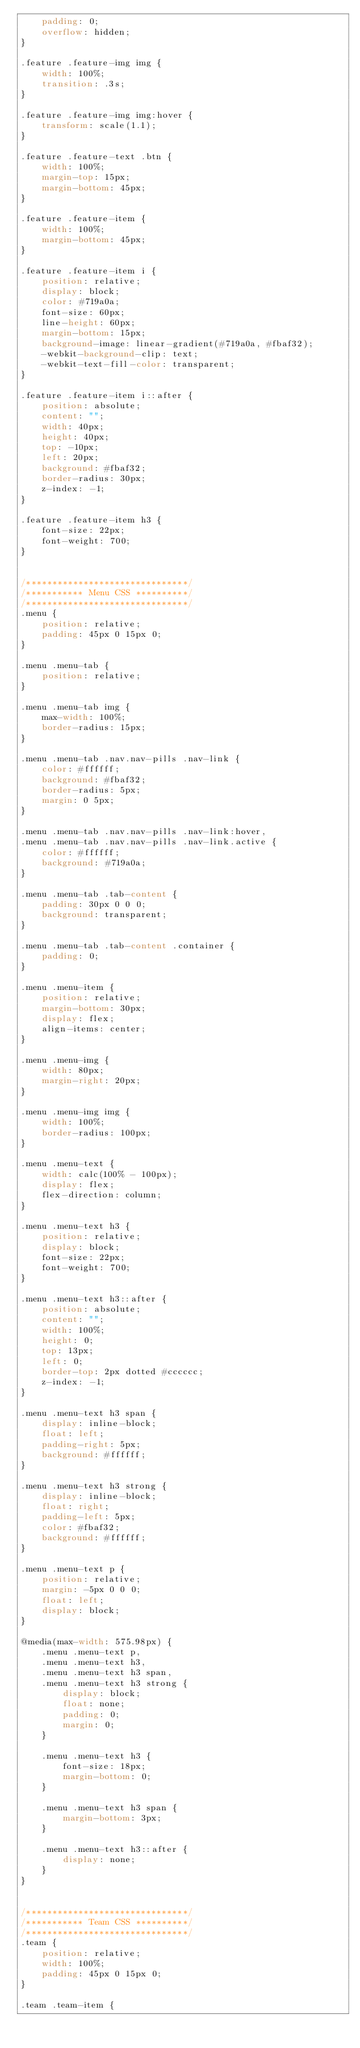<code> <loc_0><loc_0><loc_500><loc_500><_CSS_>    padding: 0;
    overflow: hidden;
}

.feature .feature-img img {
    width: 100%;
    transition: .3s;
}

.feature .feature-img img:hover {
    transform: scale(1.1);
}

.feature .feature-text .btn {
    width: 100%;
    margin-top: 15px;
    margin-bottom: 45px;
}

.feature .feature-item {
    width: 100%;
    margin-bottom: 45px;
}

.feature .feature-item i {
    position: relative;
    display: block;
    color: #719a0a;
    font-size: 60px;
    line-height: 60px;
    margin-bottom: 15px;
    background-image: linear-gradient(#719a0a, #fbaf32);
    -webkit-background-clip: text;
    -webkit-text-fill-color: transparent;
}

.feature .feature-item i::after {
    position: absolute;
    content: "";
    width: 40px;
    height: 40px;
    top: -10px;
    left: 20px;
    background: #fbaf32;
    border-radius: 30px;
    z-index: -1;
}

.feature .feature-item h3 {
    font-size: 22px;
    font-weight: 700;
}


/*******************************/
/*********** Menu CSS **********/
/*******************************/
.menu {
    position: relative;
    padding: 45px 0 15px 0;
}

.menu .menu-tab {
    position: relative;
}

.menu .menu-tab img {
    max-width: 100%;
    border-radius: 15px;
}

.menu .menu-tab .nav.nav-pills .nav-link {
    color: #ffffff;
    background: #fbaf32;
    border-radius: 5px;
    margin: 0 5px;
}

.menu .menu-tab .nav.nav-pills .nav-link:hover,
.menu .menu-tab .nav.nav-pills .nav-link.active {
    color: #ffffff;
    background: #719a0a;
}

.menu .menu-tab .tab-content {
    padding: 30px 0 0 0;
    background: transparent;
}

.menu .menu-tab .tab-content .container {
    padding: 0;
}

.menu .menu-item {
    position: relative;
    margin-bottom: 30px;
    display: flex;
    align-items: center;
}

.menu .menu-img {
    width: 80px;
    margin-right: 20px;
}

.menu .menu-img img {
    width: 100%;
    border-radius: 100px;
}

.menu .menu-text {
    width: calc(100% - 100px);
    display: flex;
    flex-direction: column;
}

.menu .menu-text h3 {
    position: relative;
    display: block;
    font-size: 22px;
    font-weight: 700;
}

.menu .menu-text h3::after {
    position: absolute;
    content: "";
    width: 100%;
    height: 0;
    top: 13px;
    left: 0;
    border-top: 2px dotted #cccccc;
    z-index: -1;
}

.menu .menu-text h3 span {
    display: inline-block;
    float: left;
    padding-right: 5px;
    background: #ffffff;
}

.menu .menu-text h3 strong {
    display: inline-block;
    float: right;
    padding-left: 5px;
    color: #fbaf32;
    background: #ffffff;
}

.menu .menu-text p {
    position: relative;
    margin: -5px 0 0 0;
    float: left;
    display: block;
}

@media(max-width: 575.98px) {
    .menu .menu-text p,
    .menu .menu-text h3,
    .menu .menu-text h3 span,
    .menu .menu-text h3 strong {
        display: block;
        float: none;
        padding: 0;
        margin: 0;
    }
    
    .menu .menu-text h3 {
        font-size: 18px;
        margin-bottom: 0;
    }
    
    .menu .menu-text h3 span {
        margin-bottom: 3px;
    }
    
    .menu .menu-text h3::after {
        display: none;
    }
}


/*******************************/
/*********** Team CSS **********/
/*******************************/
.team {
    position: relative;
    width: 100%;
    padding: 45px 0 15px 0;
}

.team .team-item {</code> 